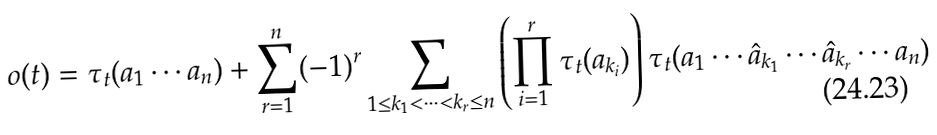Convert formula to latex. <formula><loc_0><loc_0><loc_500><loc_500>o ( t ) = \tau _ { t } ( a _ { 1 } \cdots a _ { n } ) + \sum _ { r = 1 } ^ { n } ( - 1 ) ^ { r } \sum _ { 1 \leq k _ { 1 } < \dots < k _ { r } \leq n } \left ( \prod _ { i = 1 } ^ { r } \tau _ { t } ( a _ { k _ { i } } ) \right ) \tau _ { t } ( a _ { 1 } \cdots \hat { a } _ { k _ { 1 } } \cdots \hat { a } _ { k _ { r } } \cdots a _ { n } )</formula> 